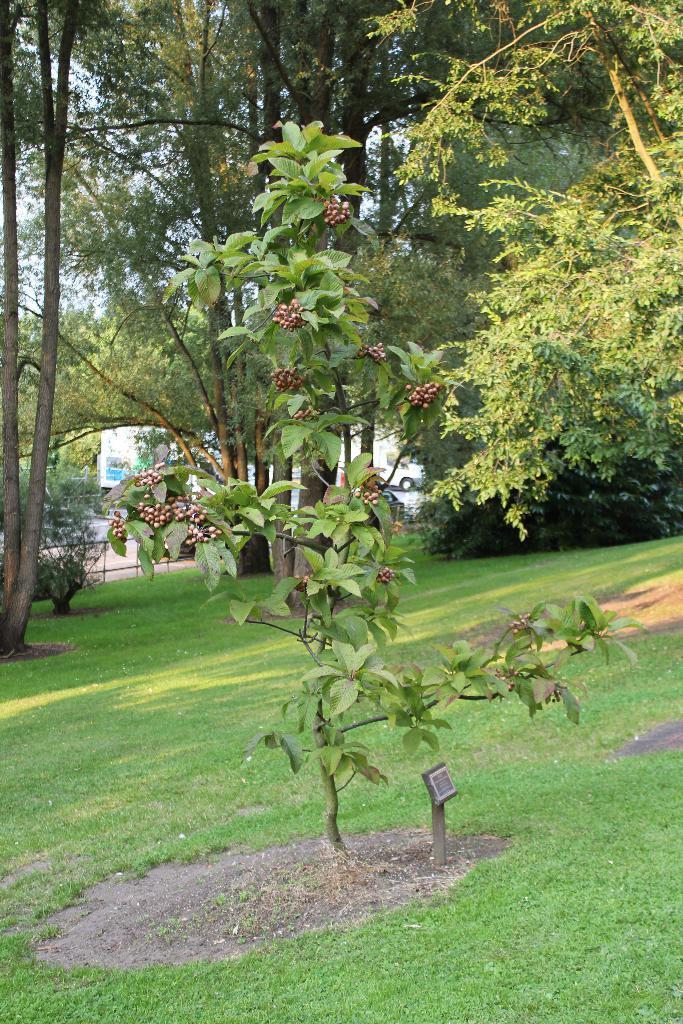Could you give a brief overview of what you see in this image? In this image, we can see a plant and in the background, there are trees. At the bottom, there is ground. 